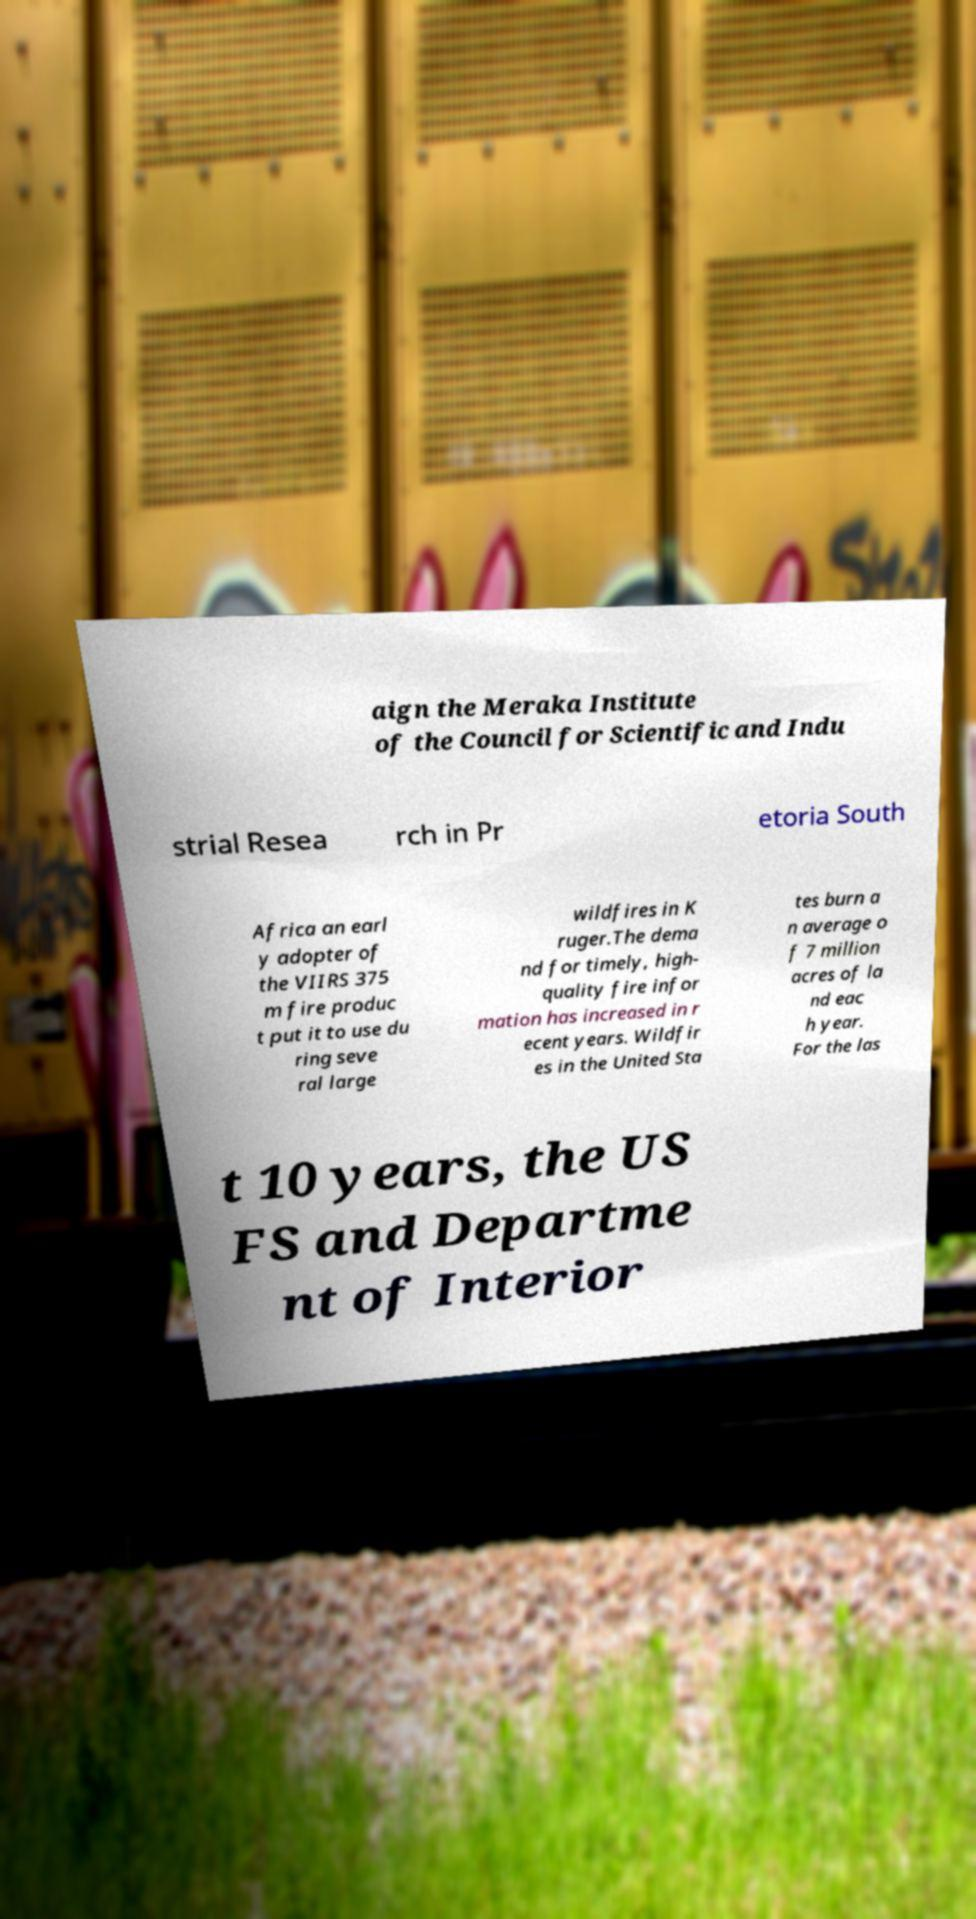There's text embedded in this image that I need extracted. Can you transcribe it verbatim? aign the Meraka Institute of the Council for Scientific and Indu strial Resea rch in Pr etoria South Africa an earl y adopter of the VIIRS 375 m fire produc t put it to use du ring seve ral large wildfires in K ruger.The dema nd for timely, high- quality fire infor mation has increased in r ecent years. Wildfir es in the United Sta tes burn a n average o f 7 million acres of la nd eac h year. For the las t 10 years, the US FS and Departme nt of Interior 